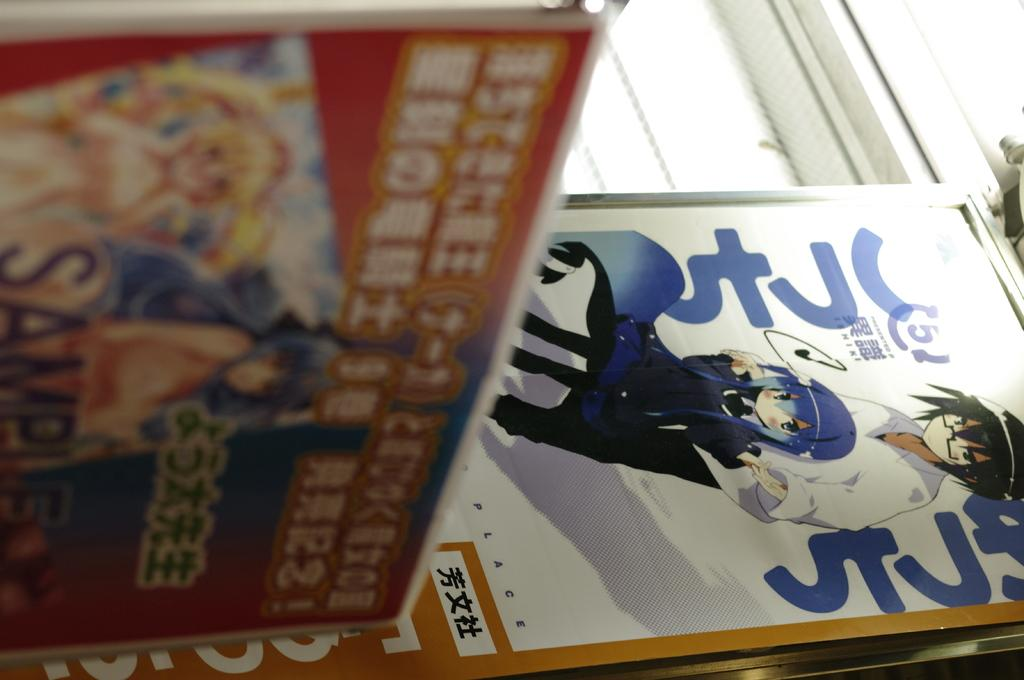What type of objects can be seen in the image? There are pom poms in the image. What style of images are present in the image? Cartoon images are present in the image. What else can be found in the image besides pom poms and cartoon images? Text is visible in the image. What type of waste can be seen in the image? There is no waste present in the image; it features pom poms, cartoon images, and text. Can you hear the cartoon images in the image? The cartoon images in the image are not audible, as they are visual representations. 